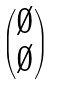Convert formula to latex. <formula><loc_0><loc_0><loc_500><loc_500>\begin{pmatrix} \emptyset \\ \emptyset \end{pmatrix}</formula> 